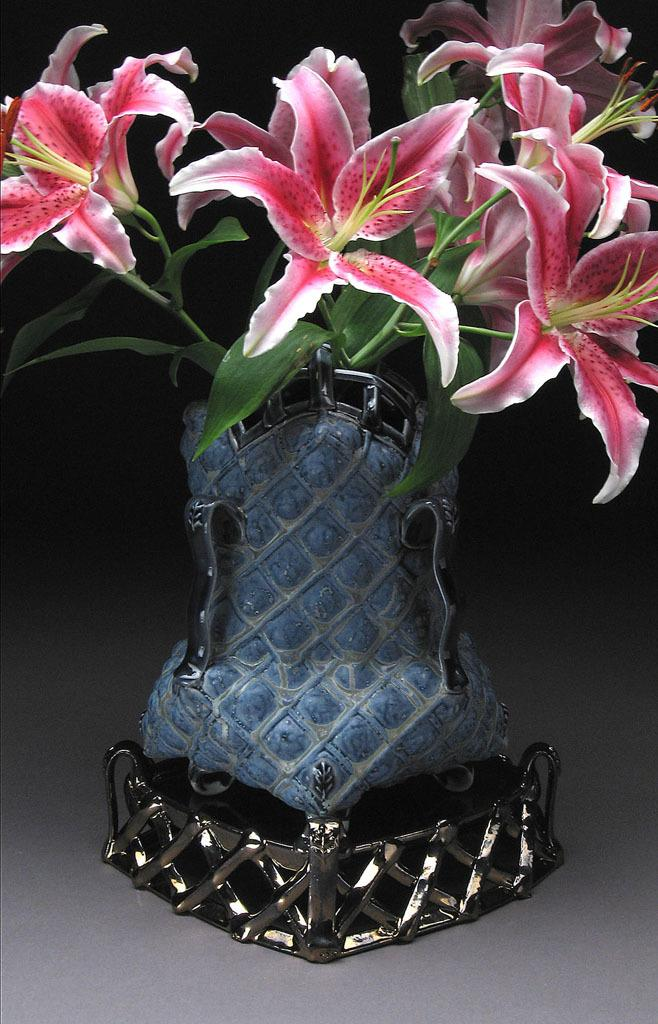What is the main object in the image? There is a flower vase in the image. What is inside the vase? The vase contains a bunch of flowers. What can be said about the color of the flowers? The flowers are pinkish in color. How would you describe the lighting or background of the image? The background of the image appears dark. How does the kitten react to the increase in the number of flowers in the vase? There is no kitten present in the image, so it is not possible to determine how a kitten might react to an increase in the number of flowers in the vase. 